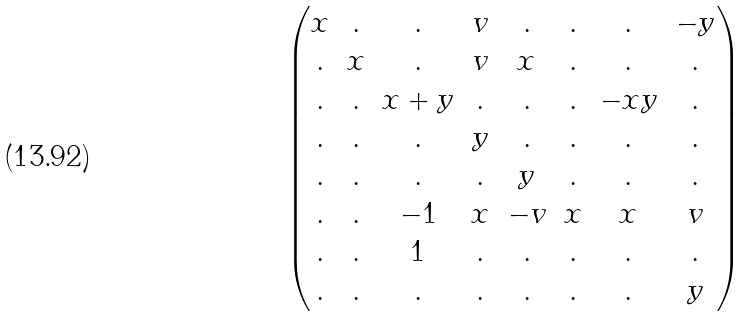<formula> <loc_0><loc_0><loc_500><loc_500>\begin{pmatrix} x & . & . & v & . & . & . & - y \\ . & x & . & v & x & . & . & . \\ . & . & x + y & . & . & . & - x y & . \\ . & . & . & y & . & . & . & . \\ . & . & . & . & y & . & . & . \\ . & . & - 1 & x & - v & x & x & v \\ . & . & 1 & . & . & . & . & . \\ . & . & . & . & . & . & . & y \\ \end{pmatrix}</formula> 